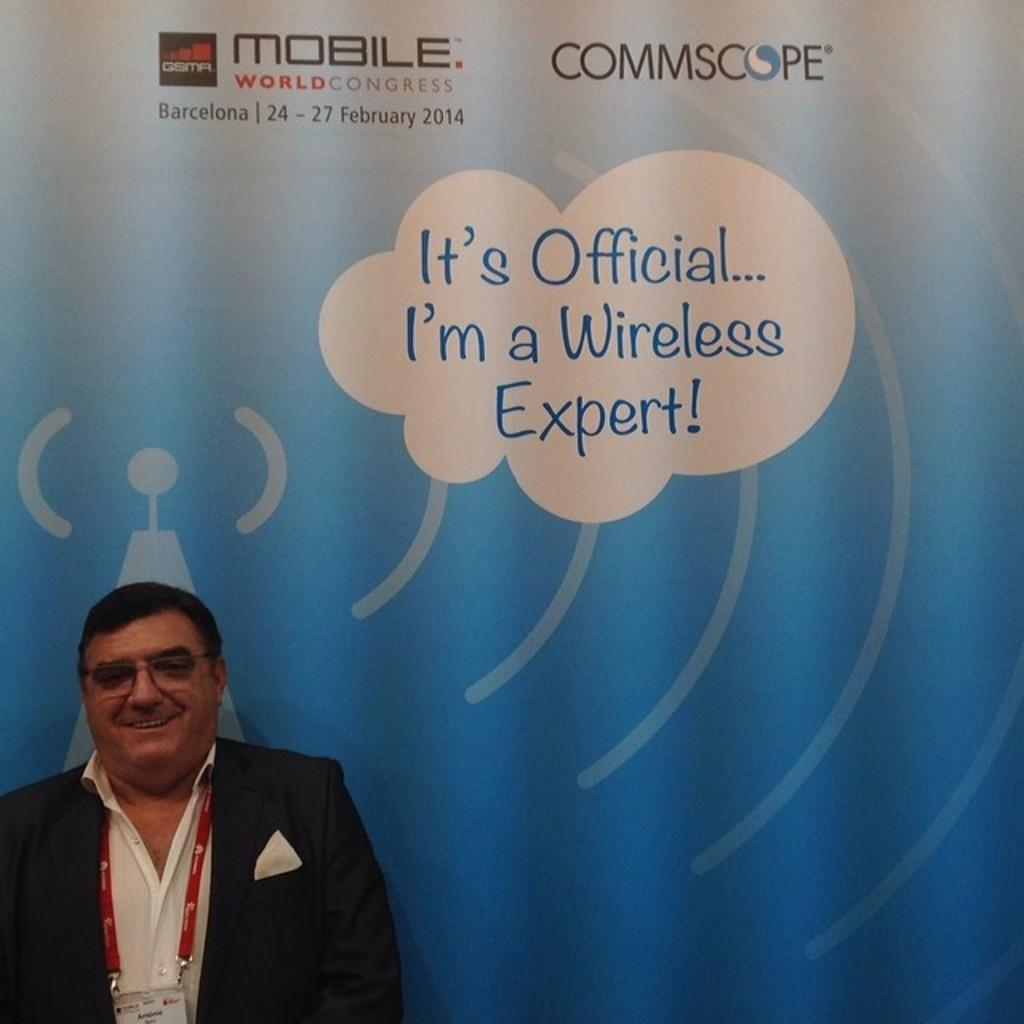Provide a one-sentence caption for the provided image. A man stands next to caption which states that he's "a wireless expert". 